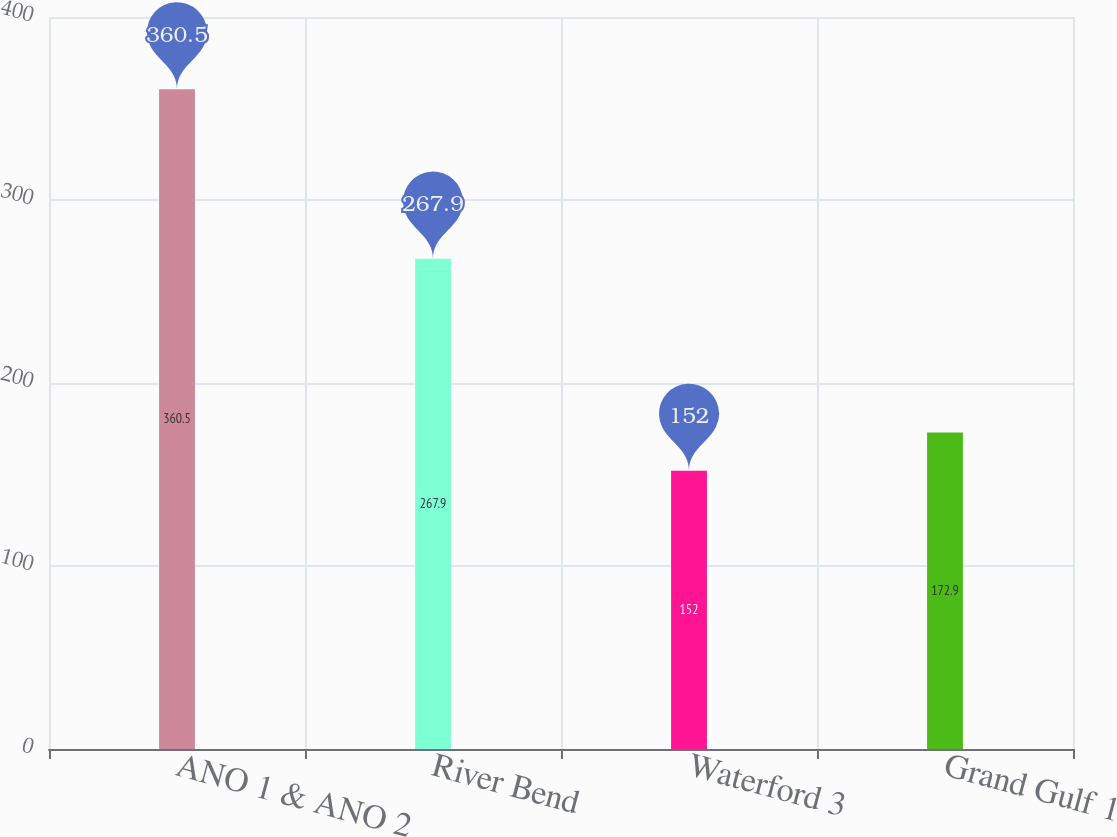Convert chart. <chart><loc_0><loc_0><loc_500><loc_500><bar_chart><fcel>ANO 1 & ANO 2<fcel>River Bend<fcel>Waterford 3<fcel>Grand Gulf 1<nl><fcel>360.5<fcel>267.9<fcel>152<fcel>172.9<nl></chart> 